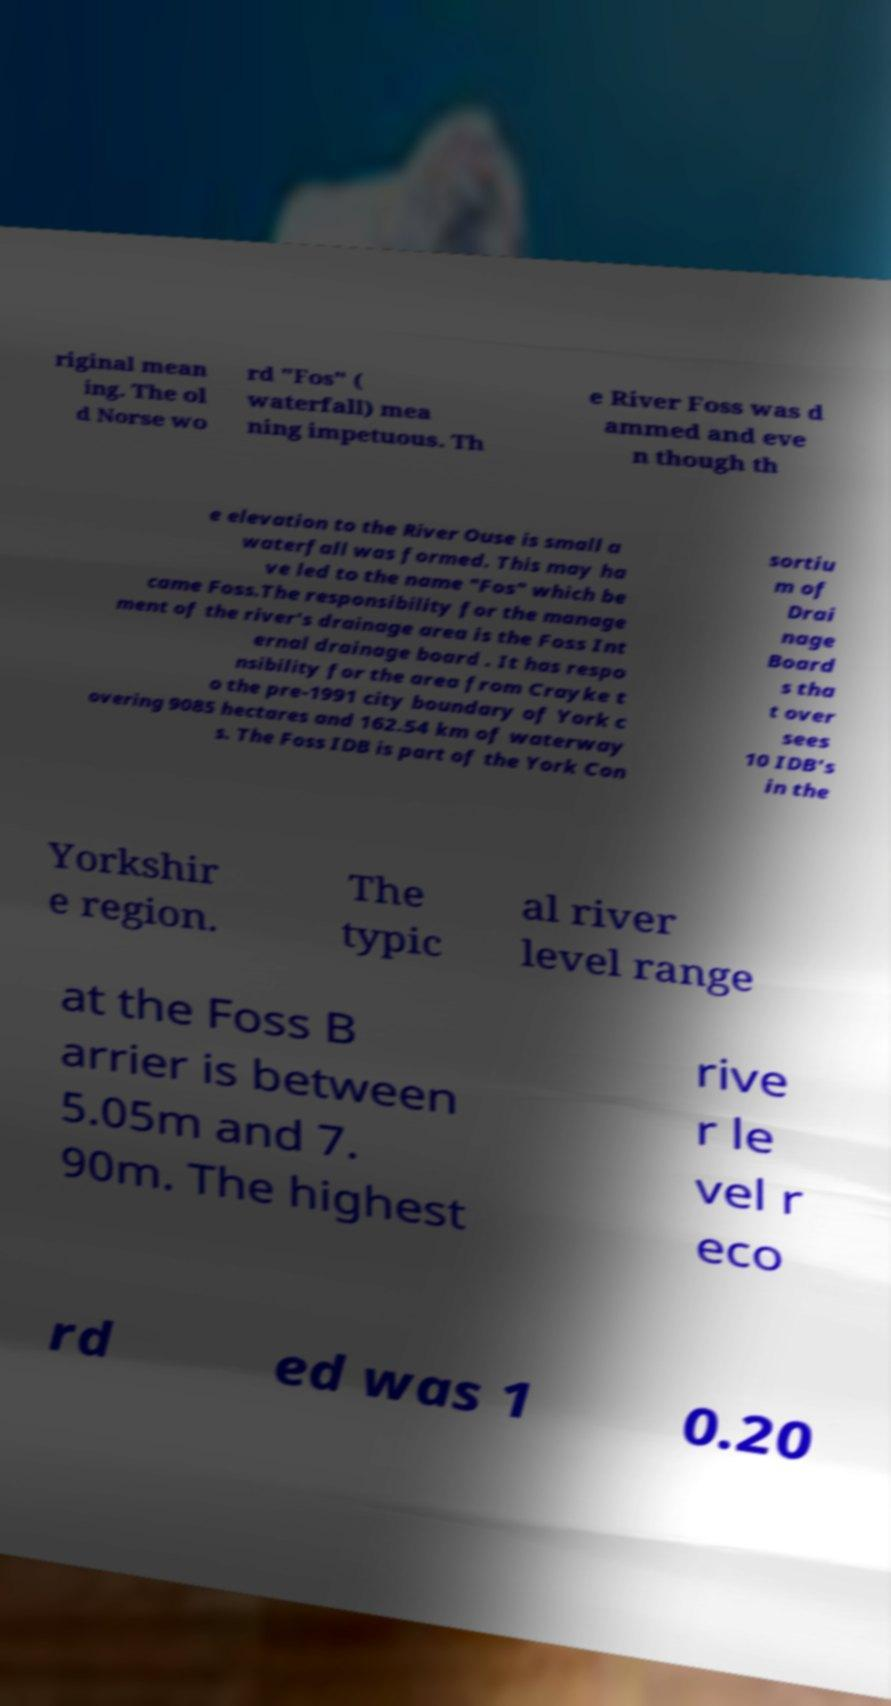Can you accurately transcribe the text from the provided image for me? riginal mean ing. The ol d Norse wo rd "Fos" ( waterfall) mea ning impetuous. Th e River Foss was d ammed and eve n though th e elevation to the River Ouse is small a waterfall was formed. This may ha ve led to the name "Fos" which be came Foss.The responsibility for the manage ment of the river's drainage area is the Foss Int ernal drainage board . It has respo nsibility for the area from Crayke t o the pre-1991 city boundary of York c overing 9085 hectares and 162.54 km of waterway s. The Foss IDB is part of the York Con sortiu m of Drai nage Board s tha t over sees 10 IDB's in the Yorkshir e region. The typic al river level range at the Foss B arrier is between 5.05m and 7. 90m. The highest rive r le vel r eco rd ed was 1 0.20 